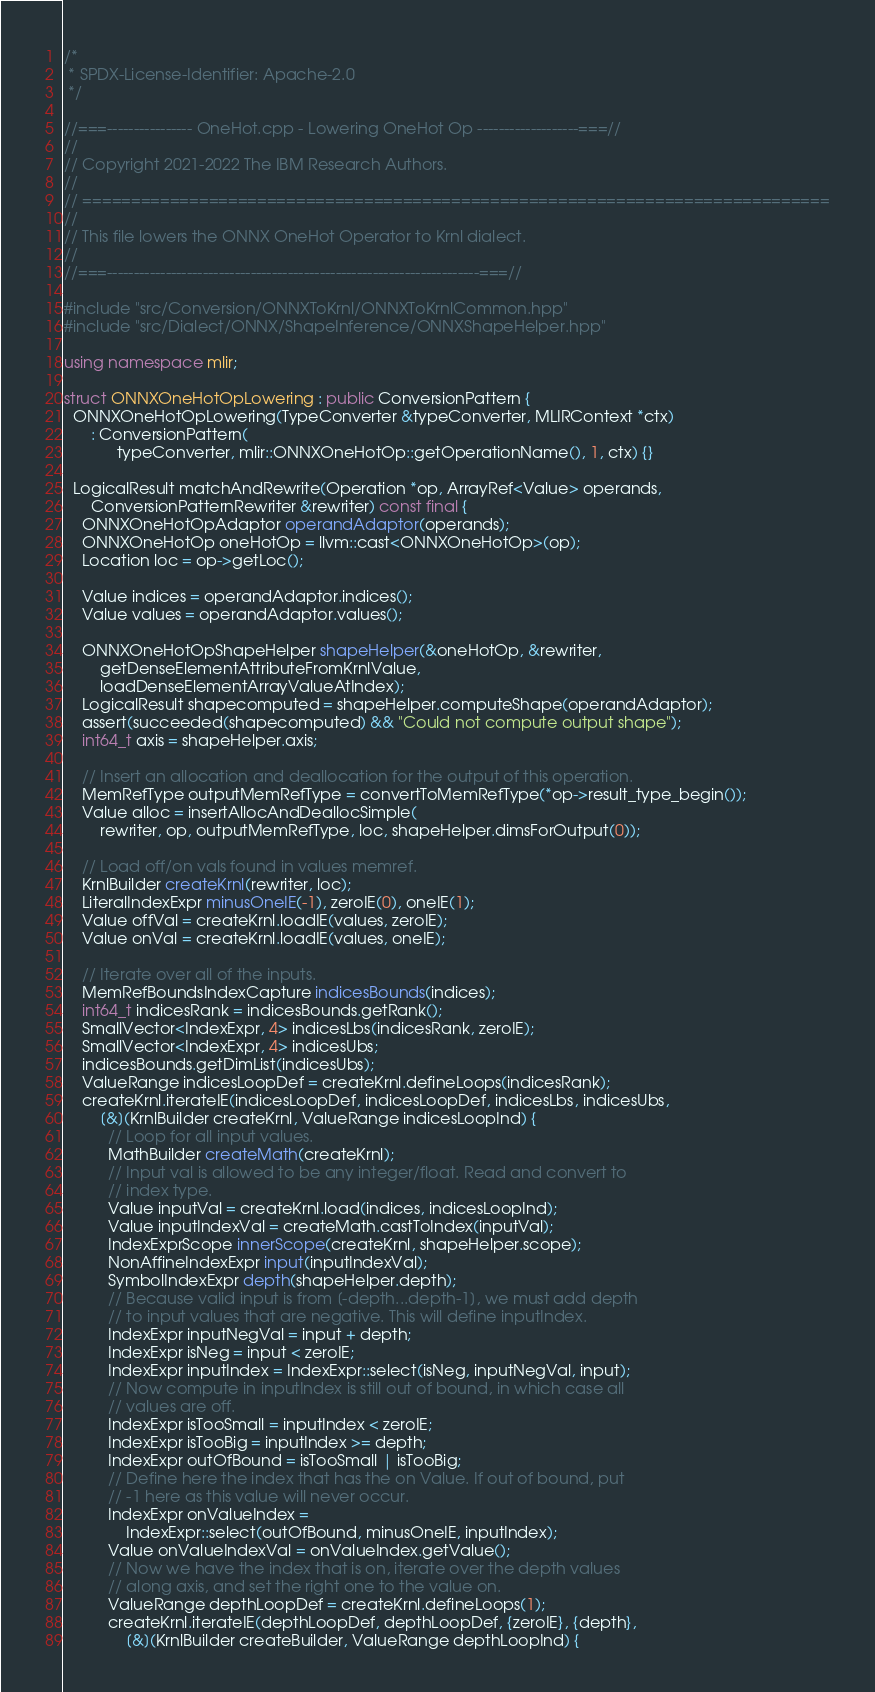<code> <loc_0><loc_0><loc_500><loc_500><_C++_>/*
 * SPDX-License-Identifier: Apache-2.0
 */

//===---------------- OneHot.cpp - Lowering OneHot Op -------------------===//
//
// Copyright 2021-2022 The IBM Research Authors.
//
// =============================================================================
//
// This file lowers the ONNX OneHot Operator to Krnl dialect.
//
//===----------------------------------------------------------------------===//

#include "src/Conversion/ONNXToKrnl/ONNXToKrnlCommon.hpp"
#include "src/Dialect/ONNX/ShapeInference/ONNXShapeHelper.hpp"

using namespace mlir;

struct ONNXOneHotOpLowering : public ConversionPattern {
  ONNXOneHotOpLowering(TypeConverter &typeConverter, MLIRContext *ctx)
      : ConversionPattern(
            typeConverter, mlir::ONNXOneHotOp::getOperationName(), 1, ctx) {}

  LogicalResult matchAndRewrite(Operation *op, ArrayRef<Value> operands,
      ConversionPatternRewriter &rewriter) const final {
    ONNXOneHotOpAdaptor operandAdaptor(operands);
    ONNXOneHotOp oneHotOp = llvm::cast<ONNXOneHotOp>(op);
    Location loc = op->getLoc();

    Value indices = operandAdaptor.indices();
    Value values = operandAdaptor.values();

    ONNXOneHotOpShapeHelper shapeHelper(&oneHotOp, &rewriter,
        getDenseElementAttributeFromKrnlValue,
        loadDenseElementArrayValueAtIndex);
    LogicalResult shapecomputed = shapeHelper.computeShape(operandAdaptor);
    assert(succeeded(shapecomputed) && "Could not compute output shape");
    int64_t axis = shapeHelper.axis;

    // Insert an allocation and deallocation for the output of this operation.
    MemRefType outputMemRefType = convertToMemRefType(*op->result_type_begin());
    Value alloc = insertAllocAndDeallocSimple(
        rewriter, op, outputMemRefType, loc, shapeHelper.dimsForOutput(0));

    // Load off/on vals found in values memref.
    KrnlBuilder createKrnl(rewriter, loc);
    LiteralIndexExpr minusOneIE(-1), zeroIE(0), oneIE(1);
    Value offVal = createKrnl.loadIE(values, zeroIE);
    Value onVal = createKrnl.loadIE(values, oneIE);

    // Iterate over all of the inputs.
    MemRefBoundsIndexCapture indicesBounds(indices);
    int64_t indicesRank = indicesBounds.getRank();
    SmallVector<IndexExpr, 4> indicesLbs(indicesRank, zeroIE);
    SmallVector<IndexExpr, 4> indicesUbs;
    indicesBounds.getDimList(indicesUbs);
    ValueRange indicesLoopDef = createKrnl.defineLoops(indicesRank);
    createKrnl.iterateIE(indicesLoopDef, indicesLoopDef, indicesLbs, indicesUbs,
        [&](KrnlBuilder createKrnl, ValueRange indicesLoopInd) {
          // Loop for all input values.
          MathBuilder createMath(createKrnl);
          // Input val is allowed to be any integer/float. Read and convert to
          // index type.
          Value inputVal = createKrnl.load(indices, indicesLoopInd);
          Value inputIndexVal = createMath.castToIndex(inputVal);
          IndexExprScope innerScope(createKrnl, shapeHelper.scope);
          NonAffineIndexExpr input(inputIndexVal);
          SymbolIndexExpr depth(shapeHelper.depth);
          // Because valid input is from [-depth...depth-1], we must add depth
          // to input values that are negative. This will define inputIndex.
          IndexExpr inputNegVal = input + depth;
          IndexExpr isNeg = input < zeroIE;
          IndexExpr inputIndex = IndexExpr::select(isNeg, inputNegVal, input);
          // Now compute in inputIndex is still out of bound, in which case all
          // values are off.
          IndexExpr isTooSmall = inputIndex < zeroIE;
          IndexExpr isTooBig = inputIndex >= depth;
          IndexExpr outOfBound = isTooSmall | isTooBig;
          // Define here the index that has the on Value. If out of bound, put
          // -1 here as this value will never occur.
          IndexExpr onValueIndex =
              IndexExpr::select(outOfBound, minusOneIE, inputIndex);
          Value onValueIndexVal = onValueIndex.getValue();
          // Now we have the index that is on, iterate over the depth values
          // along axis, and set the right one to the value on.
          ValueRange depthLoopDef = createKrnl.defineLoops(1);
          createKrnl.iterateIE(depthLoopDef, depthLoopDef, {zeroIE}, {depth},
              [&](KrnlBuilder createBuilder, ValueRange depthLoopInd) {</code> 